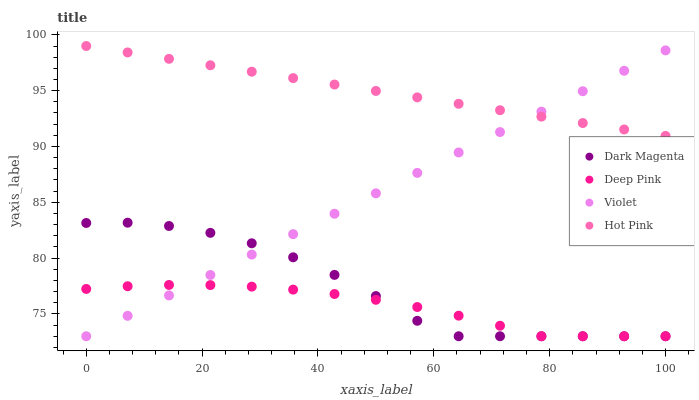Does Deep Pink have the minimum area under the curve?
Answer yes or no. Yes. Does Hot Pink have the maximum area under the curve?
Answer yes or no. Yes. Does Dark Magenta have the minimum area under the curve?
Answer yes or no. No. Does Dark Magenta have the maximum area under the curve?
Answer yes or no. No. Is Violet the smoothest?
Answer yes or no. Yes. Is Dark Magenta the roughest?
Answer yes or no. Yes. Is Deep Pink the smoothest?
Answer yes or no. No. Is Deep Pink the roughest?
Answer yes or no. No. Does Deep Pink have the lowest value?
Answer yes or no. Yes. Does Hot Pink have the highest value?
Answer yes or no. Yes. Does Dark Magenta have the highest value?
Answer yes or no. No. Is Deep Pink less than Hot Pink?
Answer yes or no. Yes. Is Hot Pink greater than Dark Magenta?
Answer yes or no. Yes. Does Violet intersect Deep Pink?
Answer yes or no. Yes. Is Violet less than Deep Pink?
Answer yes or no. No. Is Violet greater than Deep Pink?
Answer yes or no. No. Does Deep Pink intersect Hot Pink?
Answer yes or no. No. 